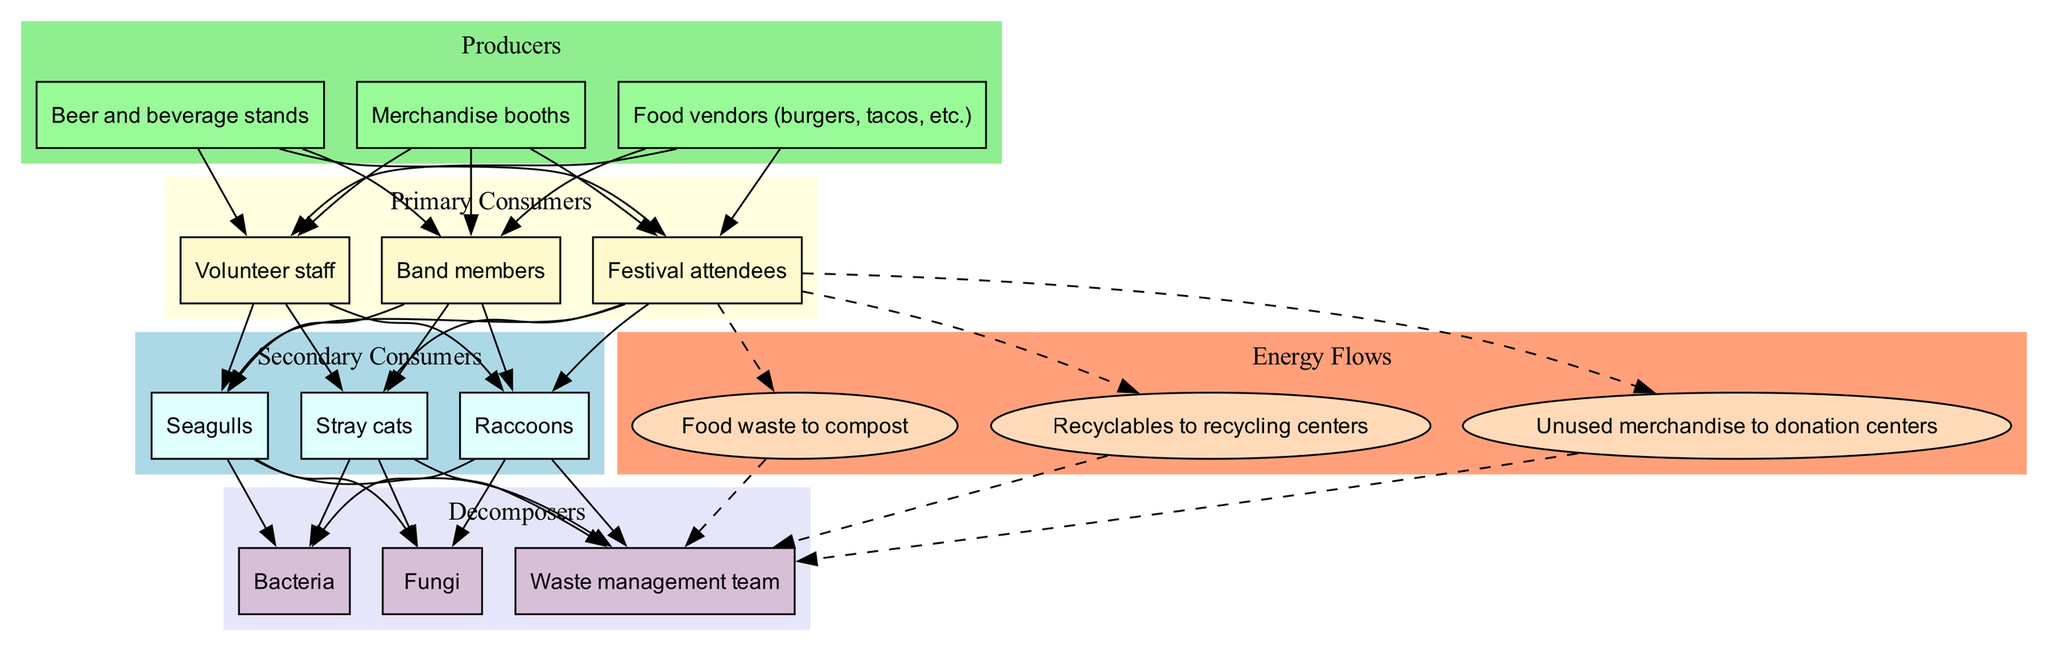What are the producers in the music festival ecosystem? The producers in the ecosystem are listed within their respective section of the diagram. They include food vendors, beverage stands, and merchandise booths.
Answer: Food vendors, beer and beverage stands, merchandise booths Which node represents primary consumers? The primary consumers section of the diagram indicates it contains festival attendees, volunteer staff, and band members.
Answer: Festival attendees, volunteer staff, band members How many secondary consumers are there? By counting the nodes listed under the secondary consumers section in the diagram, we find three: stray cats, raccoons, and seagulls.
Answer: 3 Which consumer interacts with the most producers? The diagram shows that all primary consumers are connected to every producer, indicating they all interact equally. However, since festival attendees are often considered the main audience, they have an implied stronger connection.
Answer: Festival attendees What energy flow connects primary consumers to decomposers? Following the dashed lines from primary consumers, we can see the specific flows such as food waste to compost and recycling connects them to the waste management team, a decomposer. Thus, the answer is based on a representative flow.
Answer: Food waste to compost Which type of decomposer is part of the energy flow process? The decomposers can be found in their section of the diagram, including bacteria, fungi, and the waste management team. The waste management team plays a significant role in processing the energy flow.
Answer: Waste management team Can secondary consumers feed on primary consumers? The connections drawn in the diagram indicate that secondary consumers, such as stray cats and raccoons, are linked directly to primary consumers, suggesting that they do indeed feed on them.
Answer: Yes What type of waste management is indicated in the energy flows? Within the energy flow section of the diagram, the node connecting primary consumers to decomposers specifies methods like composting and recycling. This indicates that the waste management team is involved in these processes.
Answer: Composting and recycling What is the role of bacteria in the diagram? Bacteria are situated in the decomposers section, indicating that they contribute to the breakdown of organic matter, facilitating energy return to the ecosystem.
Answer: Break down organic matter 